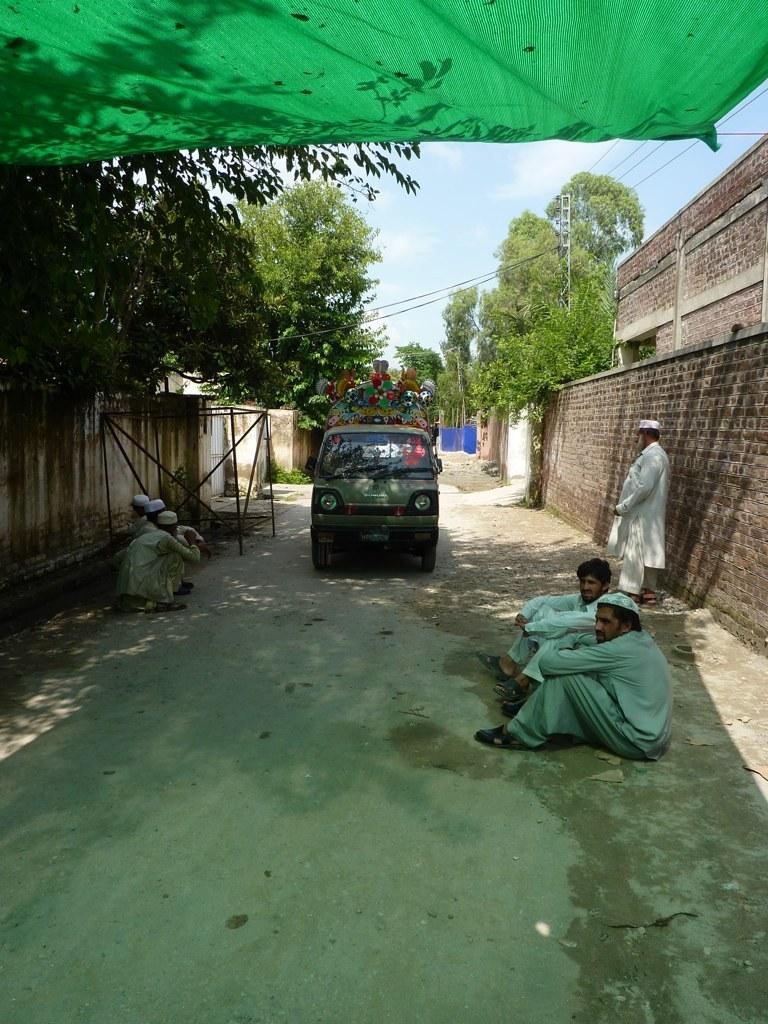How would you summarize this image in a sentence or two? In this picture there is a road in the center. On the road there is a vehicle which is in grey in color. On either side of the road there are people sitting beside the road. On the top there is a net. Towards the left and right there were buildings and trees. 